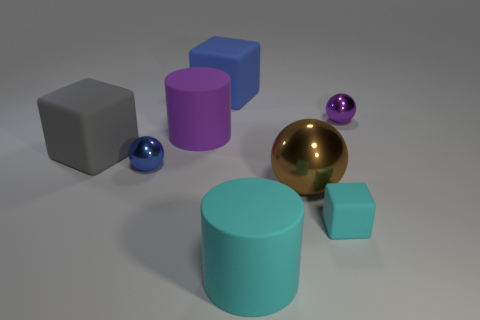What shape is the thing that is the same color as the small block?
Provide a succinct answer. Cylinder. There is a cyan rubber thing left of the small cyan cube; what shape is it?
Offer a terse response. Cylinder. Are there more metal blocks than tiny cyan blocks?
Your answer should be compact. No. Does the big cylinder that is in front of the big brown thing have the same color as the tiny rubber thing?
Give a very brief answer. Yes. How many things are small things behind the large purple cylinder or cyan blocks on the right side of the brown sphere?
Keep it short and to the point. 2. How many purple things are both right of the blue cube and left of the blue cube?
Make the answer very short. 0. Is the brown thing made of the same material as the tiny purple ball?
Ensure brevity in your answer.  Yes. What shape is the rubber object that is behind the tiny shiny ball that is to the right of the large blue cube that is behind the brown metal thing?
Provide a succinct answer. Cube. What is the tiny thing that is both in front of the gray matte block and right of the brown metallic object made of?
Give a very brief answer. Rubber. What is the color of the tiny matte object right of the small metallic ball on the left side of the tiny sphere that is to the right of the cyan matte block?
Your answer should be compact. Cyan. 